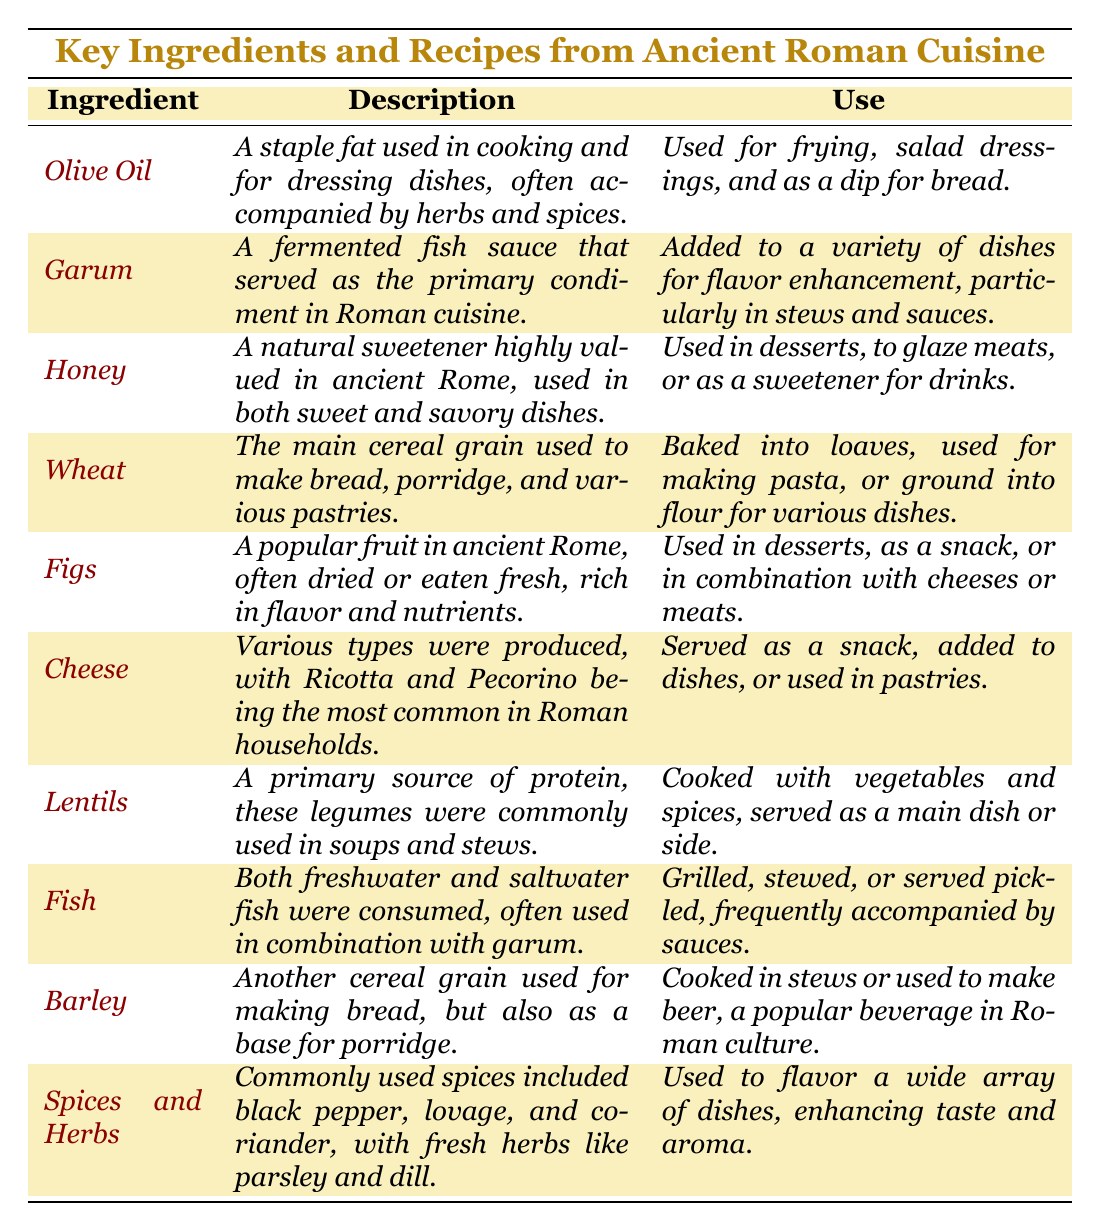What is the main use of *Garum* in Ancient Roman cuisine? The table states that *Garum* is added to a variety of dishes for flavor enhancement, particularly in stews and sauces.
Answer: Added to stews and sauces Which ingredient is primarily used for making pasta? According to the table, *Wheat* is used for making pasta, as it is the main cereal grain listed.
Answer: Wheat Is *Honey* only used in sweet dishes? The description of *Honey* indicates it is used in both sweet and savory dishes, implying it is not limited to sweet dishes.
Answer: No What two forms of fish were consumed in Ancient Rome? The table mentions both freshwater and saltwater fish were consumed, indicating the diversity of fish used.
Answer: Freshwater and saltwater fish Which ingredient from the table can also be used to glaze meats? The use of *Honey* mentioned in the table specifies that it can be used to glaze meats.
Answer: Honey How many primary sources of protein are listed in the table? Only *Lentils* is explicitly noted as a primary source of protein in the table, suggesting it is the main category described under protein sources.
Answer: One Do *Figs* serve multiple culinary purposes according to the table? The table indicates that *Figs* are used in desserts, as a snack, and in combination with cheeses or meats, confirming they serve multiple culinary purposes.
Answer: Yes Which spices or herbs are highlighted in the table for their flavoring properties? The table lists black pepper, lovage, coriander, parsley, and dill as commonly used spices and herbs, showing the variety available.
Answer: Black pepper, lovage, coriander, parsley, and dill If one wanted to use an ingredient for salad dressings, which would they choose based on the table? The table clearly states that *Olive Oil* is used for salad dressings, making it the appropriate ingredient for that use.
Answer: Olive Oil What are the uses of *Barley* mentioned in the table? The table describes that *Barley* is cooked in stews or used to make beer, indicating its dual use in cooking and beverage preparation.
Answer: Cooked in stews or used to make beer 